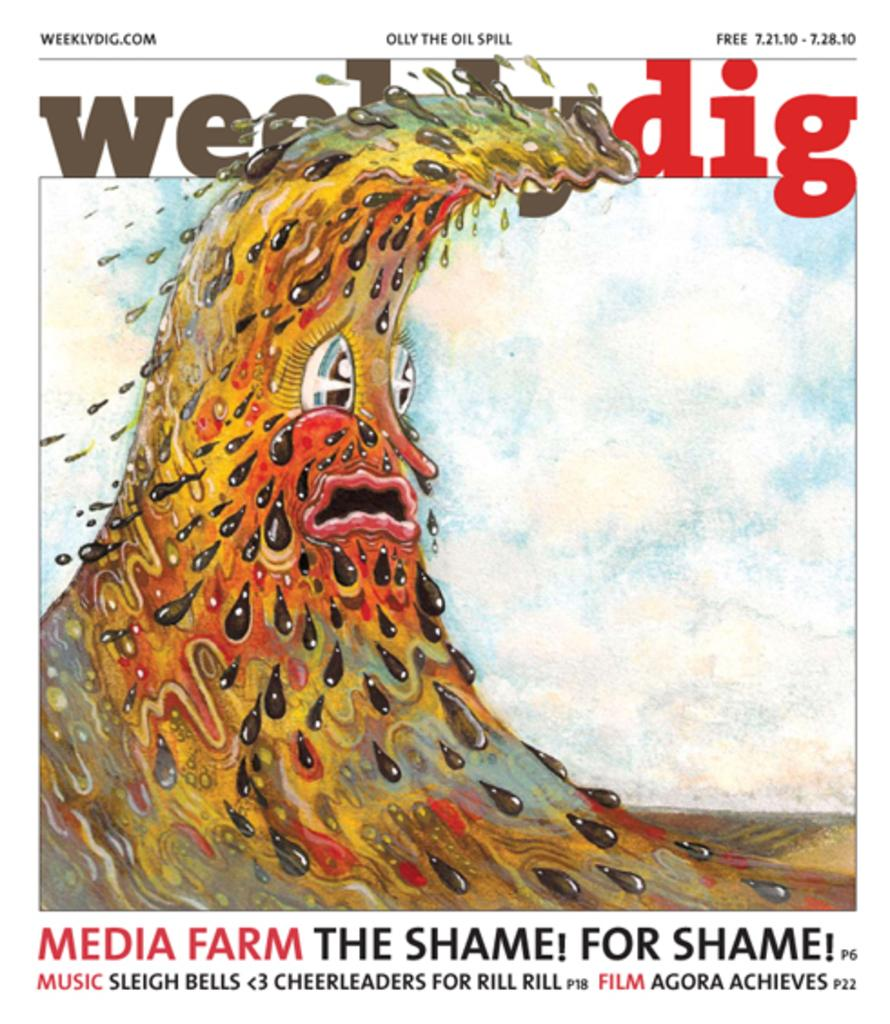<image>
Present a compact description of the photo's key features. The front of Weeklydig that says Media Farm The Shame! For Shame! along the bottom . 